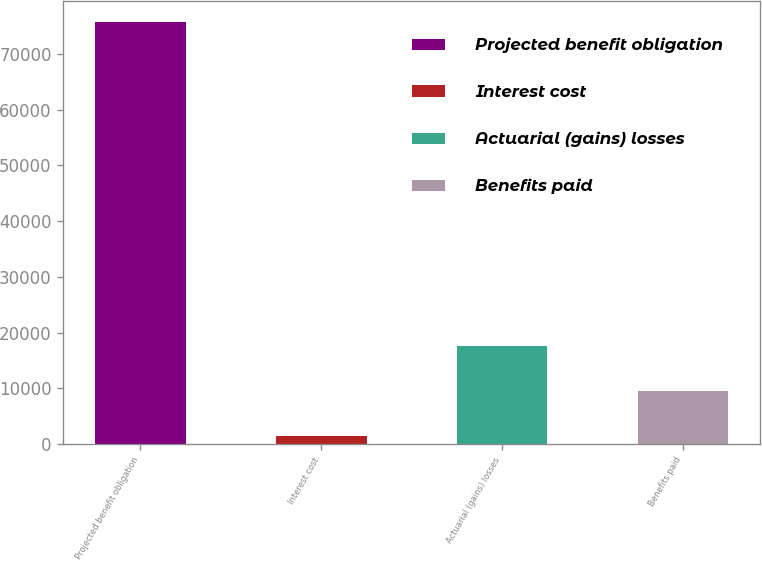Convert chart. <chart><loc_0><loc_0><loc_500><loc_500><bar_chart><fcel>Projected benefit obligation<fcel>Interest cost<fcel>Actuarial (gains) losses<fcel>Benefits paid<nl><fcel>75677<fcel>1503<fcel>17603.6<fcel>9553.3<nl></chart> 